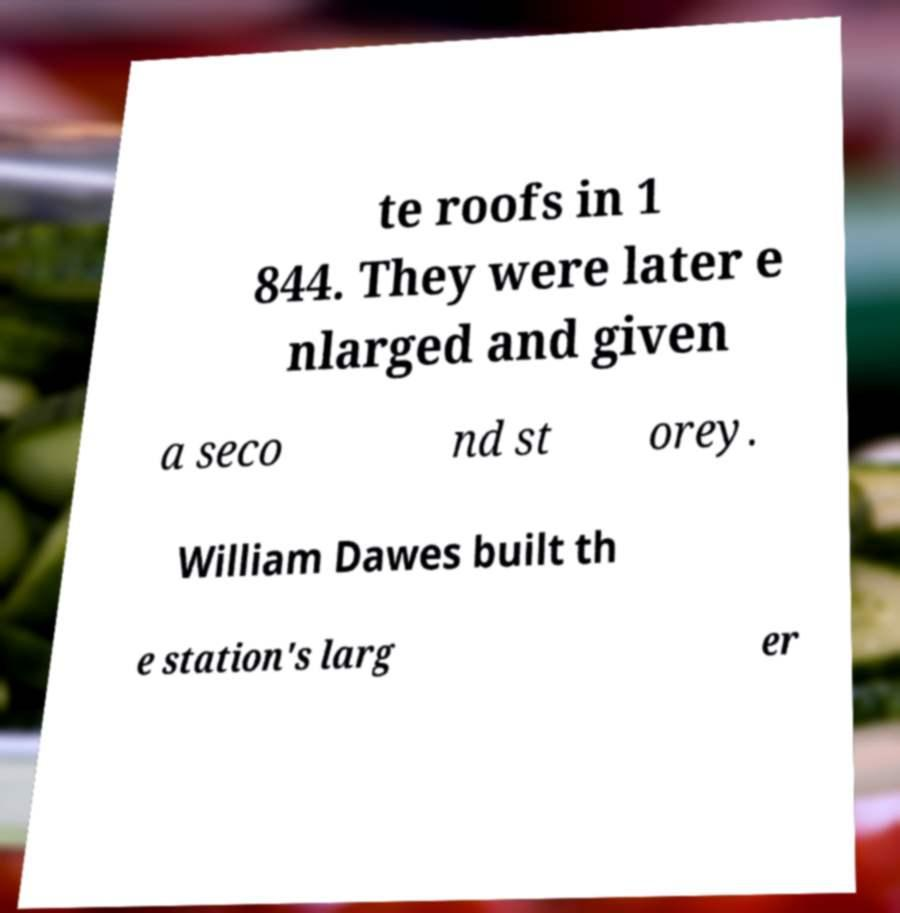Please read and relay the text visible in this image. What does it say? te roofs in 1 844. They were later e nlarged and given a seco nd st orey. William Dawes built th e station's larg er 